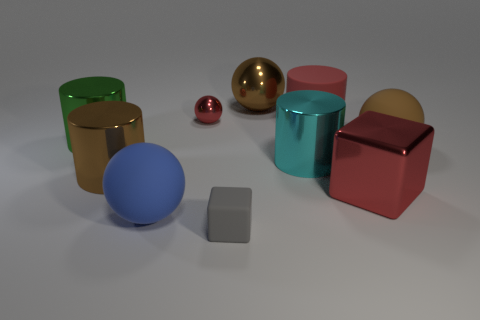Is the material of the small ball the same as the big sphere that is in front of the large metallic block?
Offer a terse response. No. There is a large rubber thing that is behind the big brown matte sphere; is its color the same as the small metal sphere?
Your answer should be very brief. Yes. What number of objects are right of the brown cylinder and behind the small block?
Keep it short and to the point. 7. How many other objects are there of the same material as the large green thing?
Offer a very short reply. 5. Is the material of the big brown ball in front of the big red cylinder the same as the small ball?
Ensure brevity in your answer.  No. There is a red ball behind the matte ball right of the big sphere in front of the large red block; how big is it?
Give a very brief answer. Small. What number of other objects are the same color as the matte cylinder?
Provide a succinct answer. 2. There is a gray rubber thing that is the same size as the red ball; what is its shape?
Offer a terse response. Cube. How big is the red ball left of the brown rubber thing?
Offer a terse response. Small. Is the color of the tiny thing behind the large cyan metal cylinder the same as the rubber object behind the big brown rubber ball?
Your answer should be compact. Yes. 